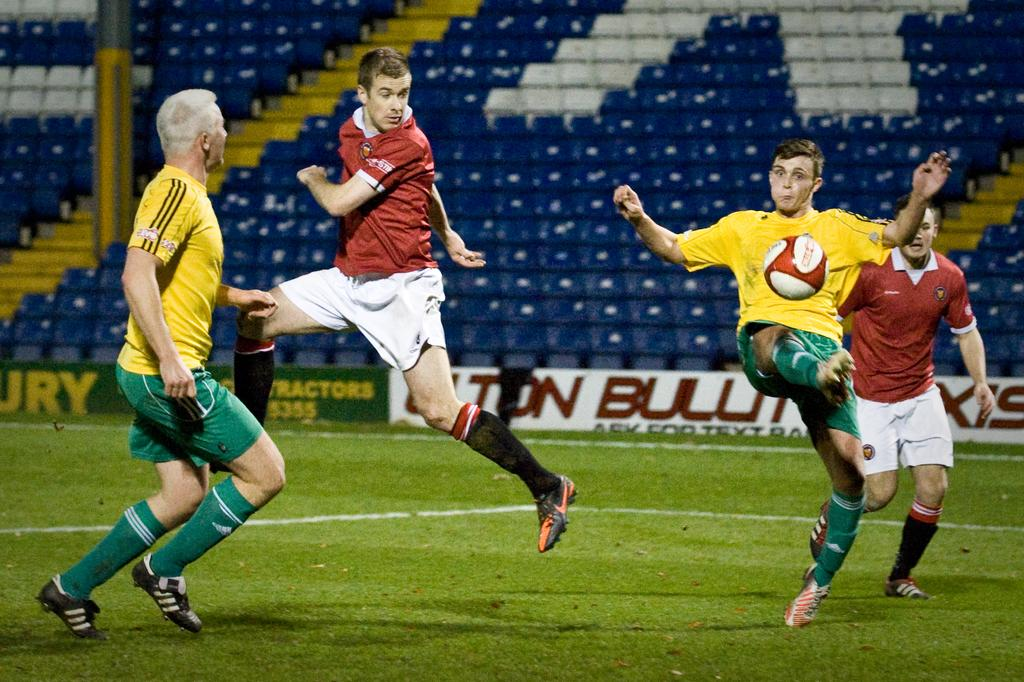<image>
Write a terse but informative summary of the picture. The yellow-shirt soccer players are wearing green Adidas socks 